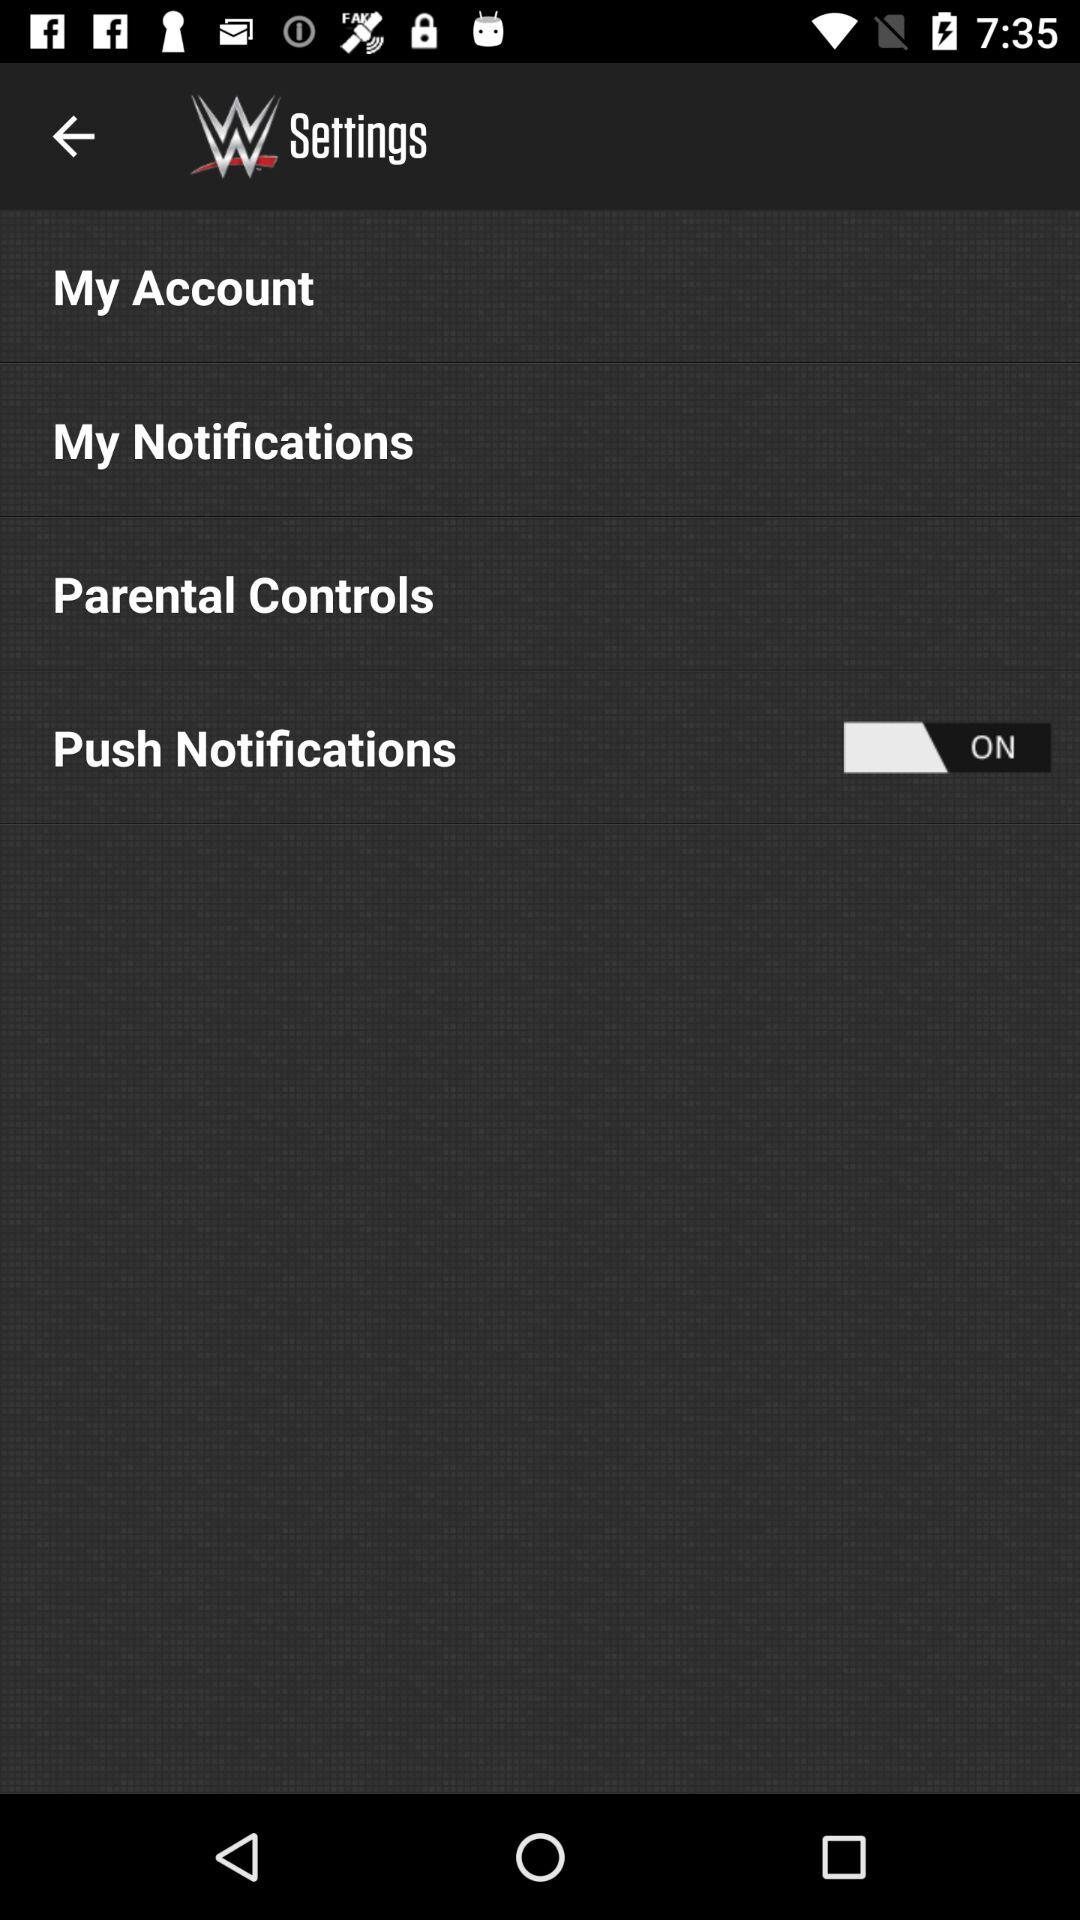What's the status of "Push Notifications"? The status is "on". 